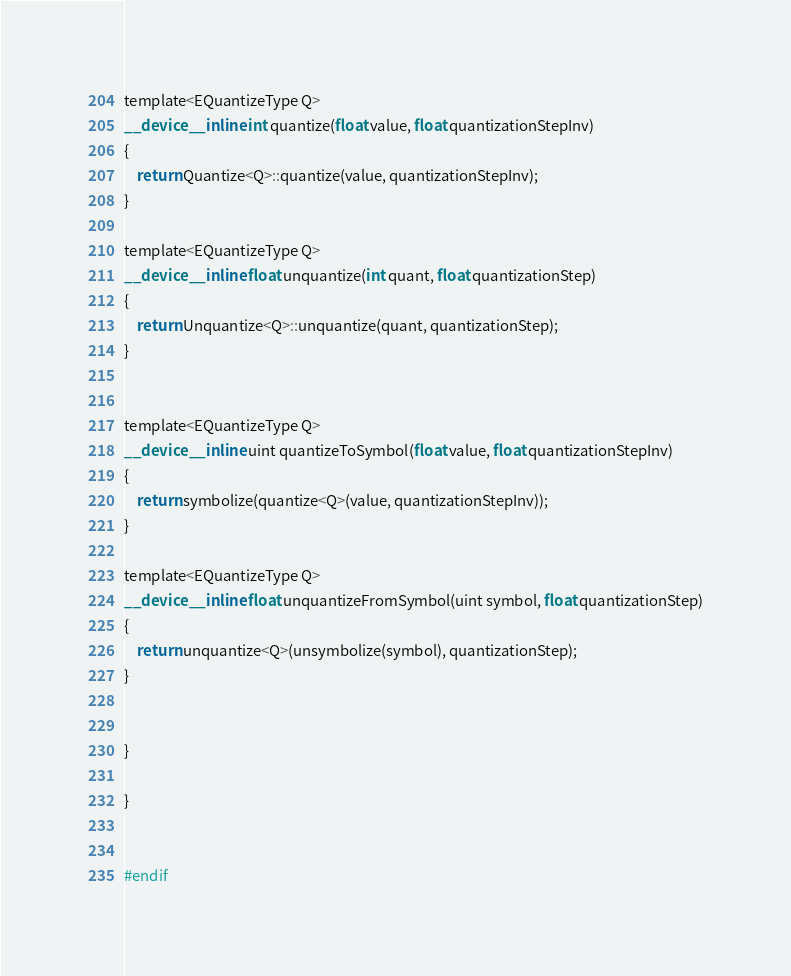<code> <loc_0><loc_0><loc_500><loc_500><_Cuda_>

template<EQuantizeType Q>
__device__ inline int quantize(float value, float quantizationStepInv)
{
    return Quantize<Q>::quantize(value, quantizationStepInv);
}

template<EQuantizeType Q>
__device__ inline float unquantize(int quant, float quantizationStep)
{
    return Unquantize<Q>::unquantize(quant, quantizationStep);
}


template<EQuantizeType Q>
__device__ inline uint quantizeToSymbol(float value, float quantizationStepInv)
{
    return symbolize(quantize<Q>(value, quantizationStepInv));
}

template<EQuantizeType Q>
__device__ inline float unquantizeFromSymbol(uint symbol, float quantizationStep)
{
    return unquantize<Q>(unsymbolize(symbol), quantizationStep);
}


}

}


#endif
</code> 